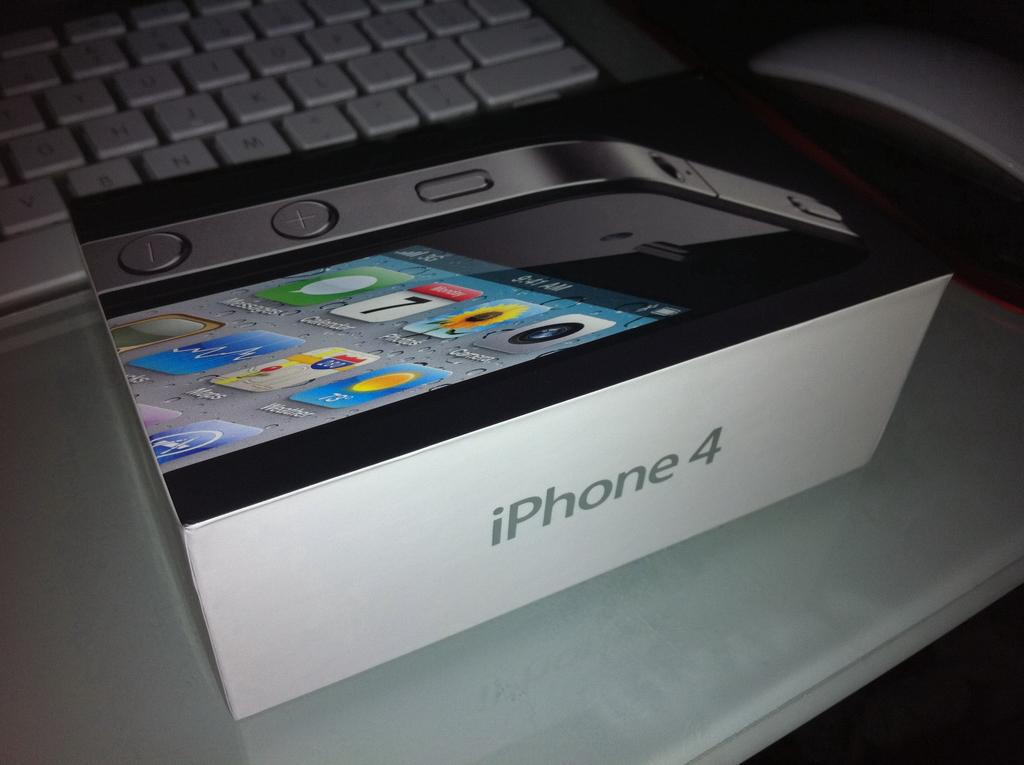<image>
Give a short and clear explanation of the subsequent image. a box that has the iPhone 4 inside of it 